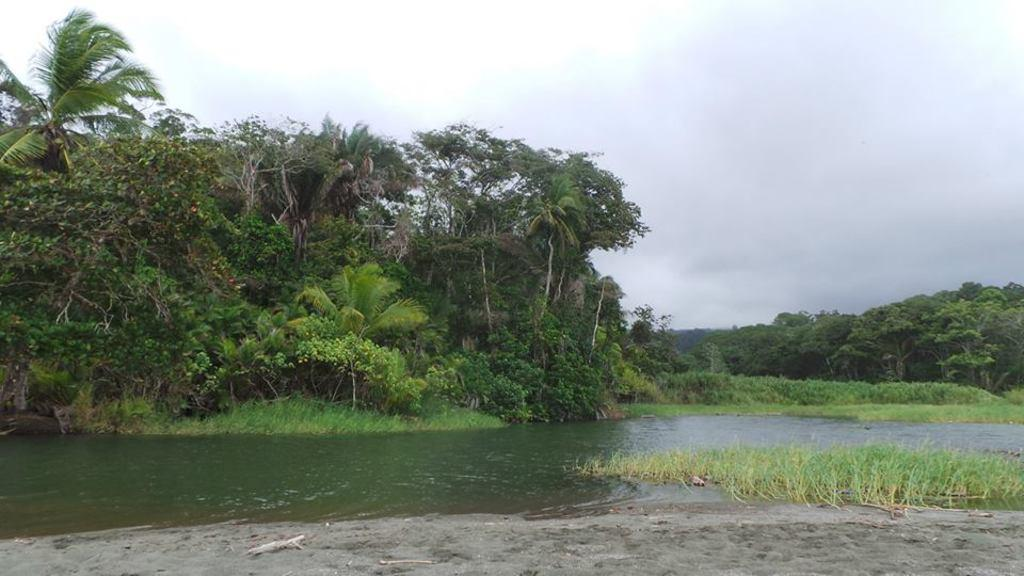What type of vegetation can be seen in the image? There are trees, plants, and grass visible in the image. What natural elements are present in the image? Water, ground, and sky are visible in the image. What is present on the ground in the image? There are objects present on the ground. What is visible in the sky in the image? The sky is visible in the image, and there are clouds present. How many rings can be seen on the trees in the image? There are no rings visible on the trees in the image, as rings are typically found on tree trunks when they are cut down, and this image does not depict any cut trees. 